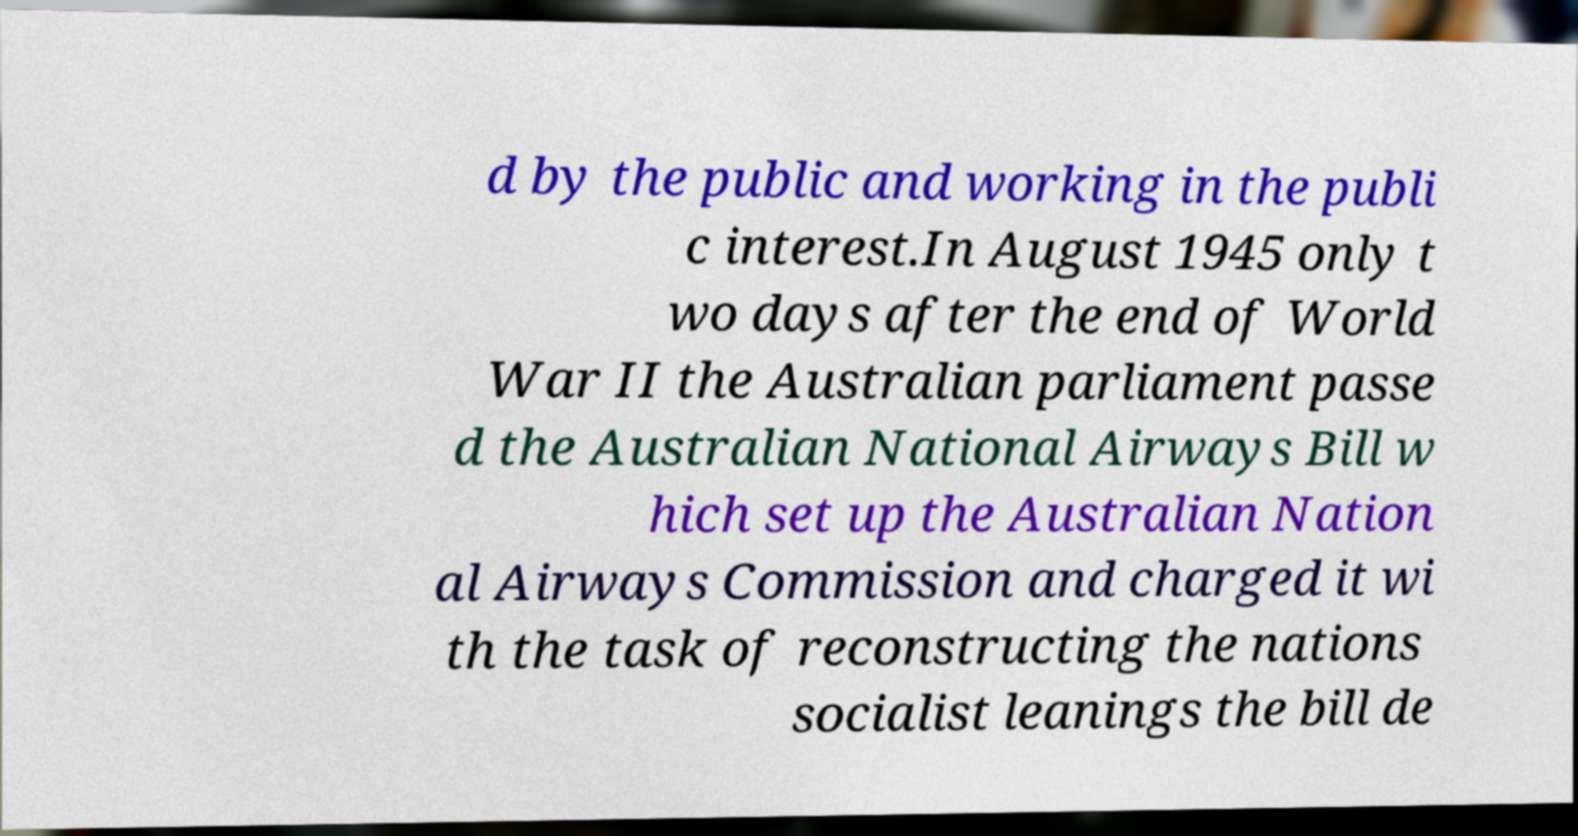Can you accurately transcribe the text from the provided image for me? d by the public and working in the publi c interest.In August 1945 only t wo days after the end of World War II the Australian parliament passe d the Australian National Airways Bill w hich set up the Australian Nation al Airways Commission and charged it wi th the task of reconstructing the nations socialist leanings the bill de 